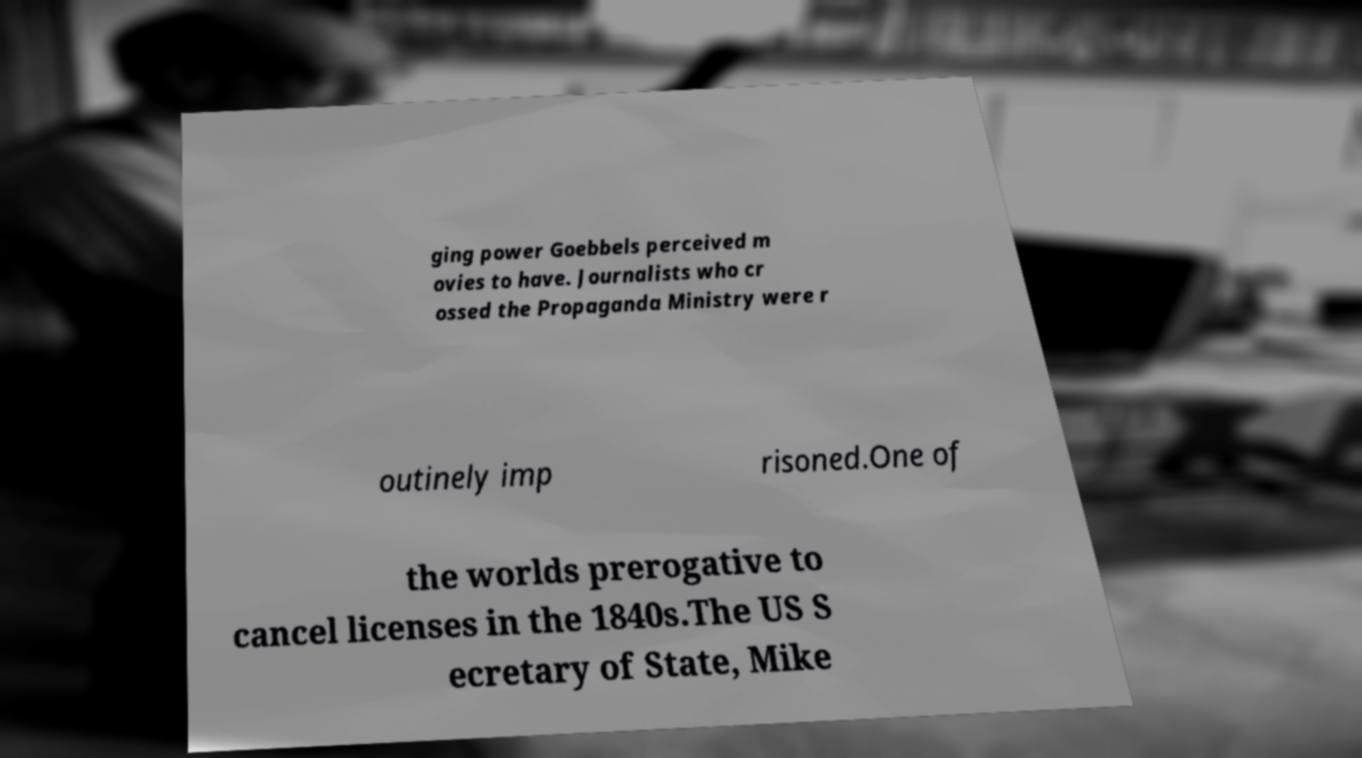Could you assist in decoding the text presented in this image and type it out clearly? ging power Goebbels perceived m ovies to have. Journalists who cr ossed the Propaganda Ministry were r outinely imp risoned.One of the worlds prerogative to cancel licenses in the 1840s.The US S ecretary of State, Mike 